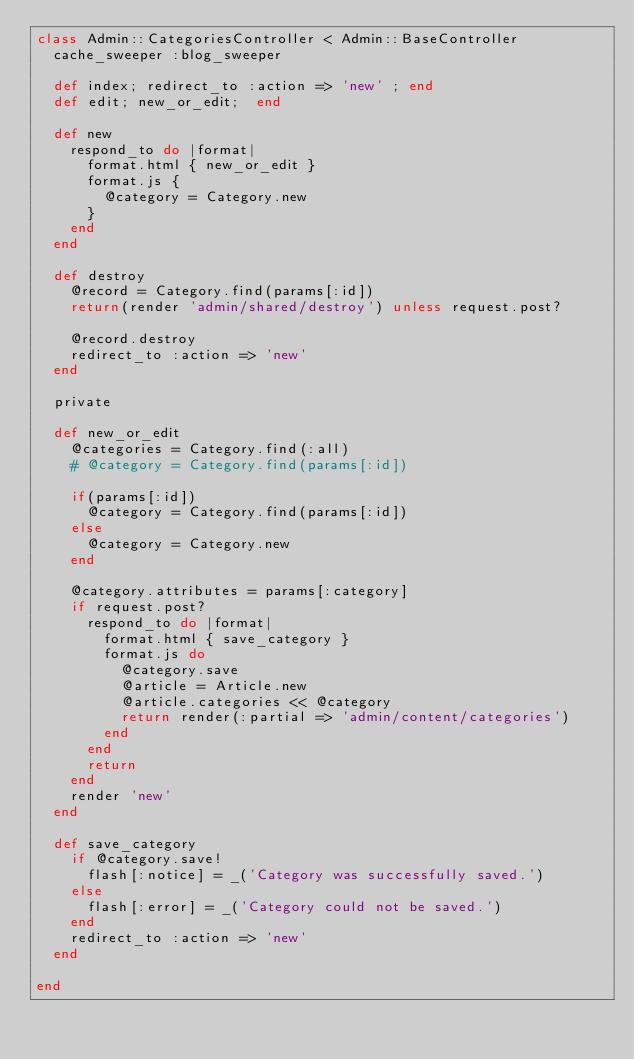<code> <loc_0><loc_0><loc_500><loc_500><_Ruby_>class Admin::CategoriesController < Admin::BaseController
  cache_sweeper :blog_sweeper

  def index; redirect_to :action => 'new' ; end
  def edit; new_or_edit;  end

  def new 
    respond_to do |format|
      format.html { new_or_edit }
      format.js { 
        @category = Category.new
      }
    end
  end

  def destroy
    @record = Category.find(params[:id])
    return(render 'admin/shared/destroy') unless request.post?

    @record.destroy
    redirect_to :action => 'new'
  end

  private

  def new_or_edit
    @categories = Category.find(:all)
    # @category = Category.find(params[:id])

    if(params[:id])
      @category = Category.find(params[:id])
    else
      @category = Category.new
    end
    
    @category.attributes = params[:category]
    if request.post?
      respond_to do |format|
        format.html { save_category }
        format.js do 
          @category.save
          @article = Article.new
          @article.categories << @category
          return render(:partial => 'admin/content/categories')
        end
      end
      return
    end
    render 'new'
  end

  def save_category
    if @category.save!
      flash[:notice] = _('Category was successfully saved.')
    else
      flash[:error] = _('Category could not be saved.')
    end
    redirect_to :action => 'new'
  end

end
</code> 